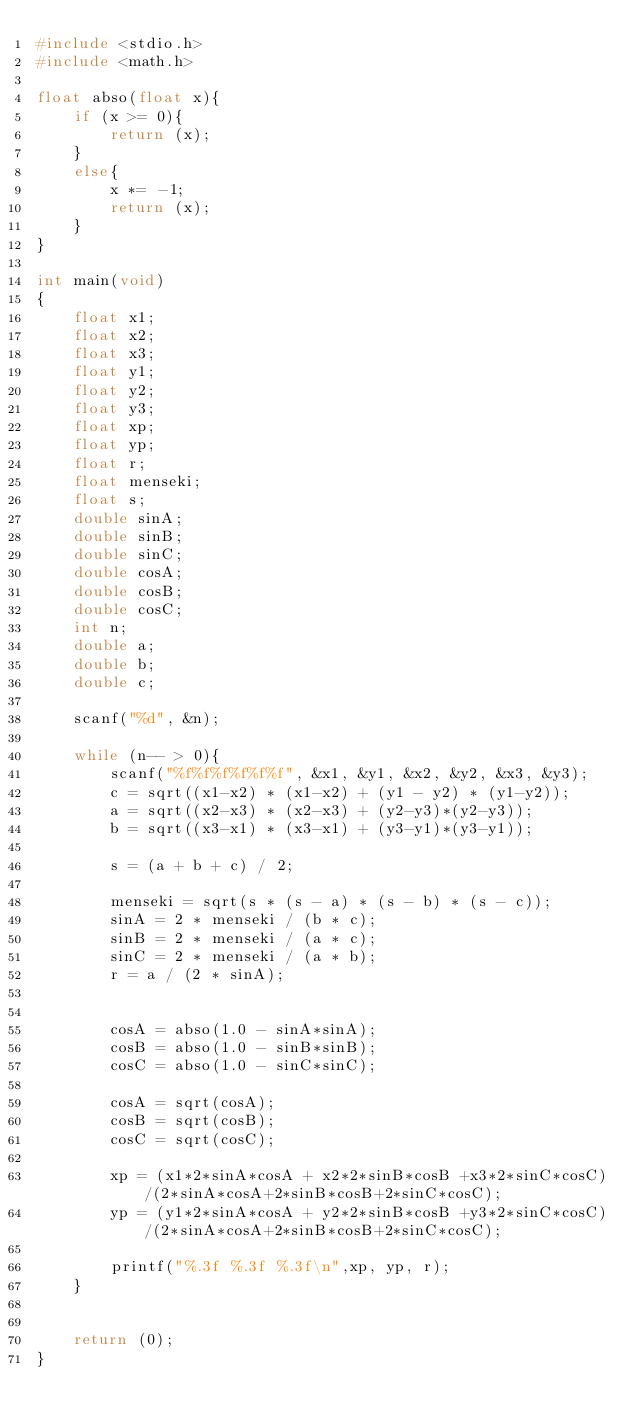<code> <loc_0><loc_0><loc_500><loc_500><_C_>#include <stdio.h>
#include <math.h>

float abso(float x){
	if (x >= 0){
		return (x);
	}
	else{
		x *= -1;
		return (x);
	}
}

int main(void)
{
	float x1;
	float x2;
	float x3;
	float y1;
	float y2;
	float y3;
	float xp;
	float yp;
	float r;
	float menseki;
	float s;
	double sinA;
	double sinB;
	double sinC;
	double cosA;
	double cosB;
	double cosC;
	int n;
	double a;
	double b;
	double c;
	
	scanf("%d", &n);
	
	while (n-- > 0){
		scanf("%f%f%f%f%f%f", &x1, &y1, &x2, &y2, &x3, &y3);
		c = sqrt((x1-x2) * (x1-x2) + (y1 - y2) * (y1-y2));
		a = sqrt((x2-x3) * (x2-x3) + (y2-y3)*(y2-y3));
		b = sqrt((x3-x1) * (x3-x1) + (y3-y1)*(y3-y1));
		
		s = (a + b + c) / 2;
		
		menseki = sqrt(s * (s - a) * (s - b) * (s - c));
		sinA = 2 * menseki / (b * c);
		sinB = 2 * menseki / (a * c);
		sinC = 2 * menseki / (a * b);
		r = a / (2 * sinA);
		
		
		cosA = abso(1.0 - sinA*sinA);
		cosB = abso(1.0 - sinB*sinB);
		cosC = abso(1.0 - sinC*sinC);
		
		cosA = sqrt(cosA);
		cosB = sqrt(cosB);
		cosC = sqrt(cosC);
		
		xp = (x1*2*sinA*cosA + x2*2*sinB*cosB +x3*2*sinC*cosC)/(2*sinA*cosA+2*sinB*cosB+2*sinC*cosC);
		yp = (y1*2*sinA*cosA + y2*2*sinB*cosB +y3*2*sinC*cosC)/(2*sinA*cosA+2*sinB*cosB+2*sinC*cosC);
		
		printf("%.3f %.3f %.3f\n",xp, yp, r);
	}
	
	
	return (0);
}</code> 